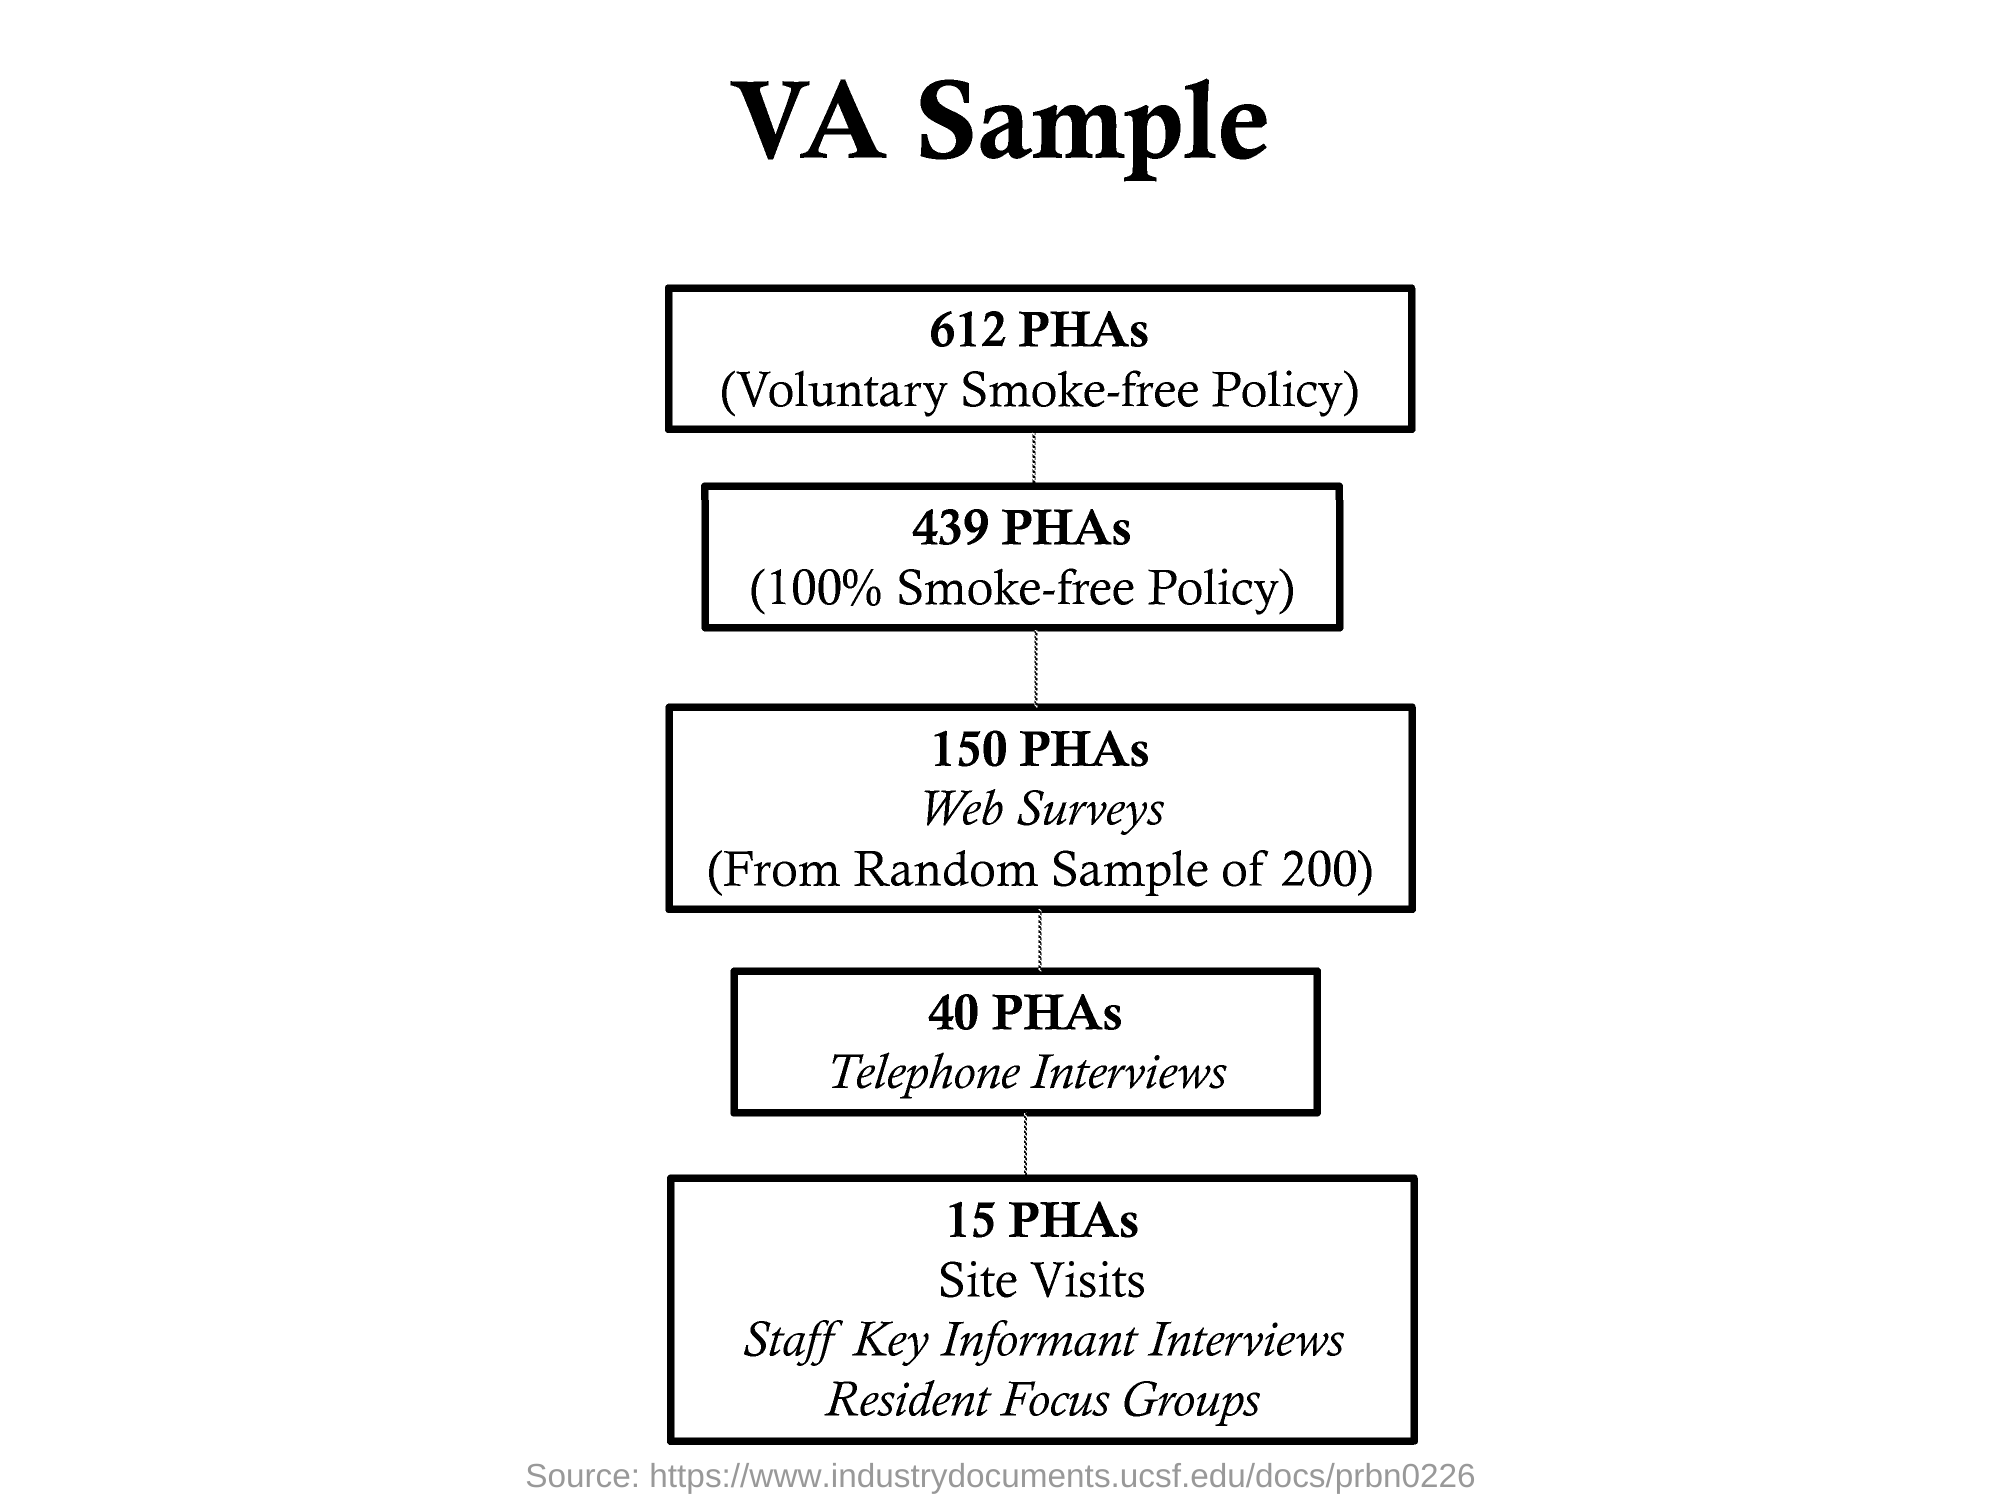What is the title of this flowchart?
Offer a terse response. VA Sample. How many random samples are taken for the web surveys?
Give a very brief answer. 200. 